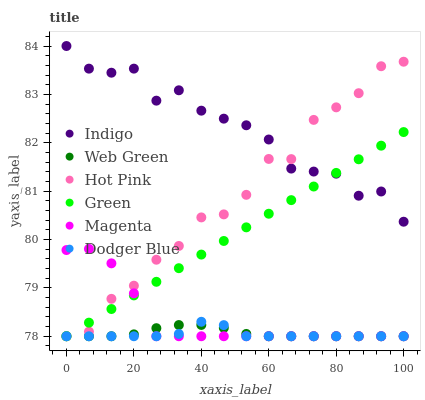Does Dodger Blue have the minimum area under the curve?
Answer yes or no. Yes. Does Indigo have the maximum area under the curve?
Answer yes or no. Yes. Does Hot Pink have the minimum area under the curve?
Answer yes or no. No. Does Hot Pink have the maximum area under the curve?
Answer yes or no. No. Is Green the smoothest?
Answer yes or no. Yes. Is Hot Pink the roughest?
Answer yes or no. Yes. Is Web Green the smoothest?
Answer yes or no. No. Is Web Green the roughest?
Answer yes or no. No. Does Hot Pink have the lowest value?
Answer yes or no. Yes. Does Indigo have the highest value?
Answer yes or no. Yes. Does Hot Pink have the highest value?
Answer yes or no. No. Is Dodger Blue less than Indigo?
Answer yes or no. Yes. Is Indigo greater than Web Green?
Answer yes or no. Yes. Does Dodger Blue intersect Green?
Answer yes or no. Yes. Is Dodger Blue less than Green?
Answer yes or no. No. Is Dodger Blue greater than Green?
Answer yes or no. No. Does Dodger Blue intersect Indigo?
Answer yes or no. No. 